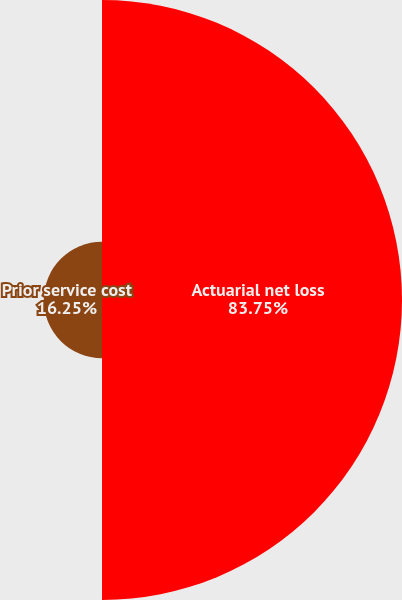Convert chart to OTSL. <chart><loc_0><loc_0><loc_500><loc_500><pie_chart><fcel>Actuarial net loss<fcel>Prior service cost<nl><fcel>83.75%<fcel>16.25%<nl></chart> 